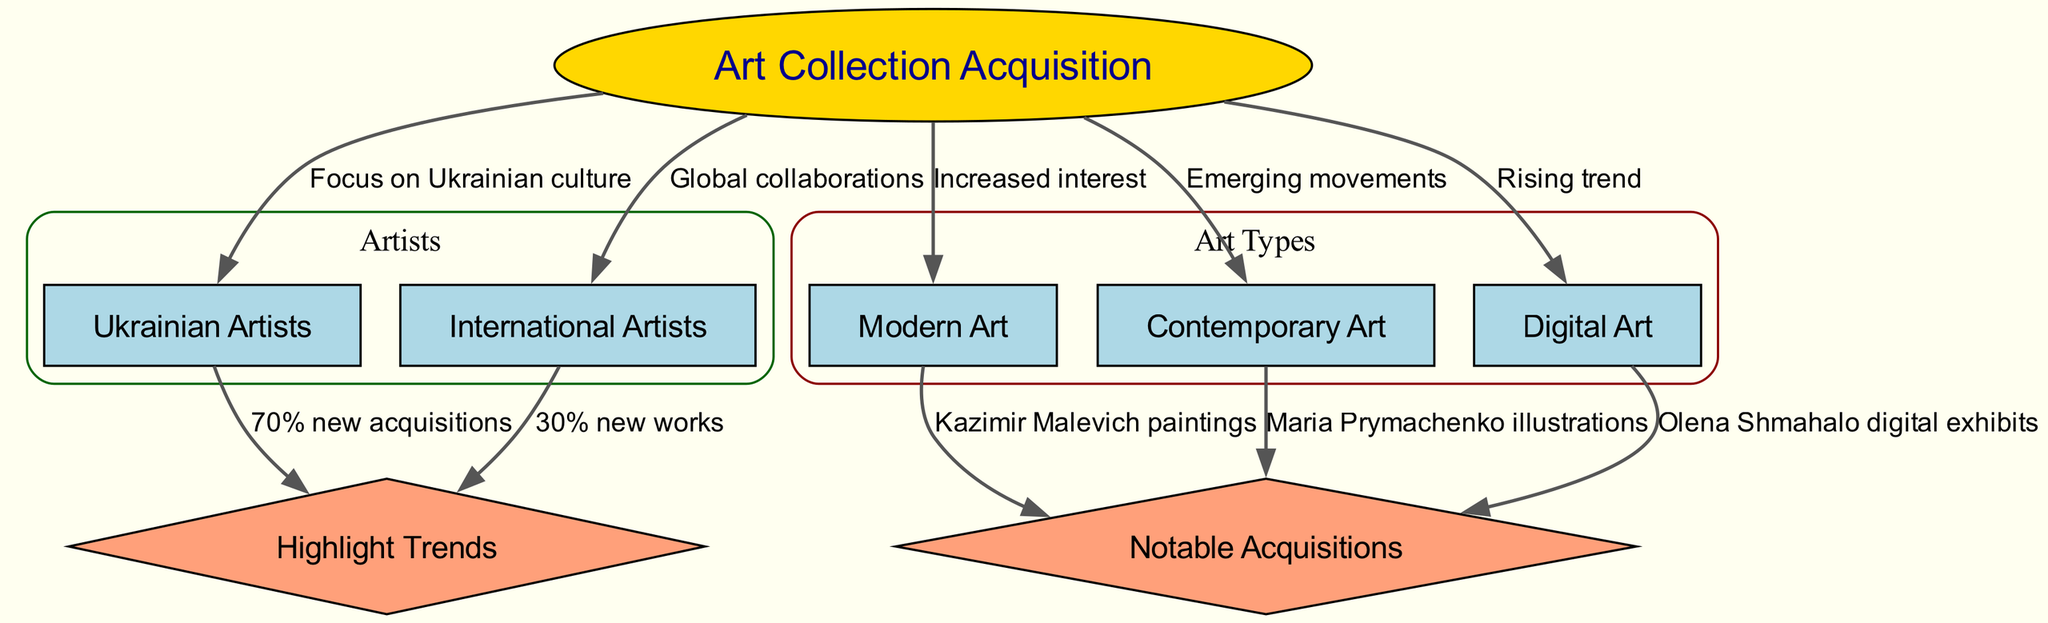What are the three main types of art highlighted in the diagram? The nodes representing the types of art indicate Modern Art, Contemporary Art, and Digital Art. These nodes can be identified directly in the diagram, and by listing them, we can see they are distinctly mentioned.
Answer: Modern Art, Contemporary Art, Digital Art How many notable acquisitions are listed in the diagram? The edges pointing to the Notable Acquisitions node depict three significant pieces: Kazimir Malevich paintings, Maria Prymachenko illustrations, and Olena Shmahalo digital exhibits. Counting these connections provides the number of notable acquisitions.
Answer: 3 What percentage of new acquisitions come from Ukrainian artists? The edge from the Ukrainian Artists node to Highlight Trends indicates that 70% of the new acquisitions are attributed to them, as described directly in the diagram.
Answer: 70% What constitutes the primary focus of the art collection acquisitions according to the diagram? The diagram illustrates that the Art Collection Acquisition node has a direct edge to the Ukrainian Artists node, indicating a focus on Ukrainian culture. This focus is supported by the labeled edge that specifies the relationship.
Answer: Focus on Ukrainian culture What is the ratio of new works acquired from international artists compared to Ukrainian artists? To determine the ratio, note that 30% of new works are from international artists and 70% from Ukrainian artists. This indicates a ratio of 30:70, which can also be simplified to 3:7.
Answer: 3:7 Which type of art is increasingly popular according to the trends in the diagram? The edge from Art Collection Acquisition to Digital Art represents a rising trend in this field. This relationship is clearly shown in the diagram as it specifically points out this increase in interest.
Answer: Digital Art What type of art has notable acquisitions specifically linked to Kazimir Malevich? The Modern Art node has a direct edge to the Notable Acquisitions node, which specifies Kazimir Malevich paintings as notable. This connection confirms that Kazimir Malevich is associated with Modern Art in the context of acquisitions.
Answer: Modern Art What is the significance of the 70% mentioned in relation to Ukrainian artists? The 70% figure is specified in the edge linking Ukrainian Artists to Highlight Trends, indicating that a significant majority of the new acquisitions in the art collection come from Ukrainian artists. This percentage highlights the emphasis placed on local artistic contributions.
Answer: 70% 